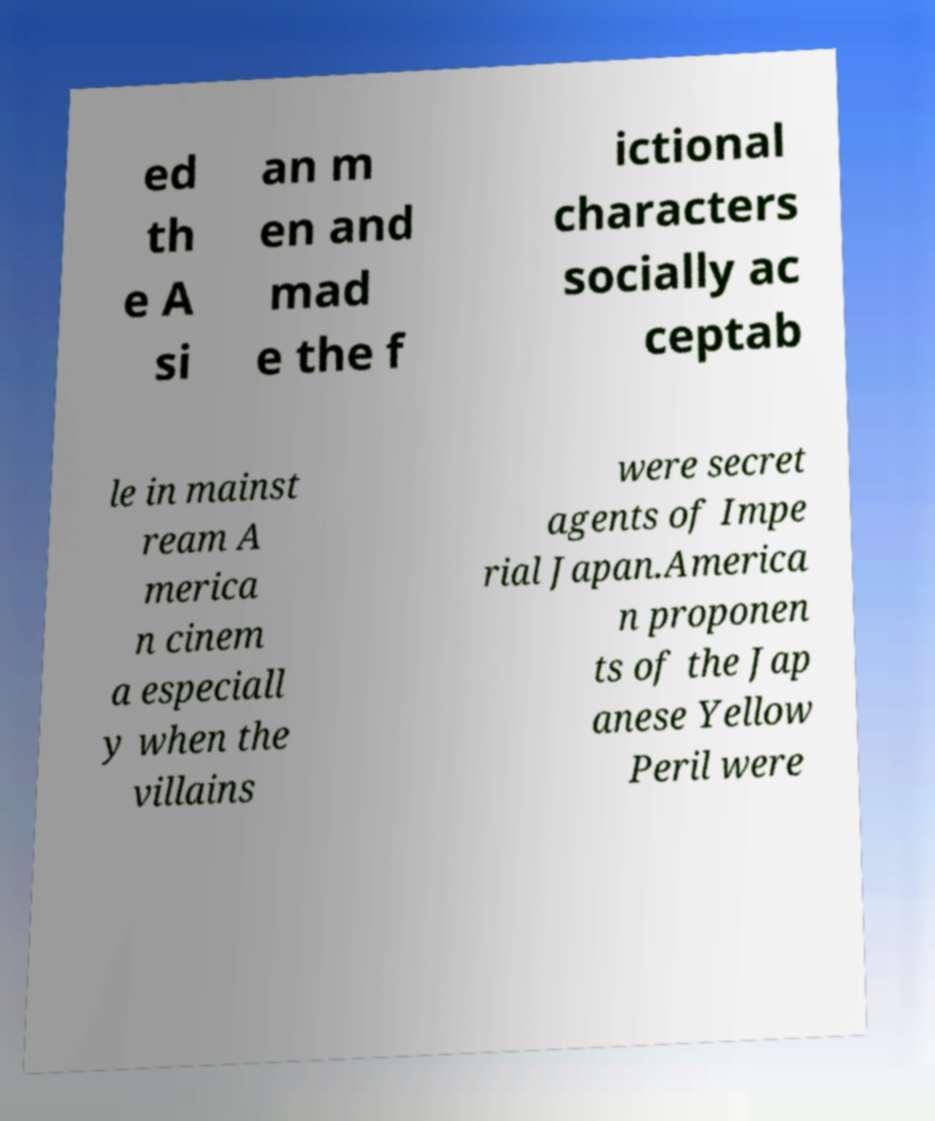Can you read and provide the text displayed in the image?This photo seems to have some interesting text. Can you extract and type it out for me? ed th e A si an m en and mad e the f ictional characters socially ac ceptab le in mainst ream A merica n cinem a especiall y when the villains were secret agents of Impe rial Japan.America n proponen ts of the Jap anese Yellow Peril were 